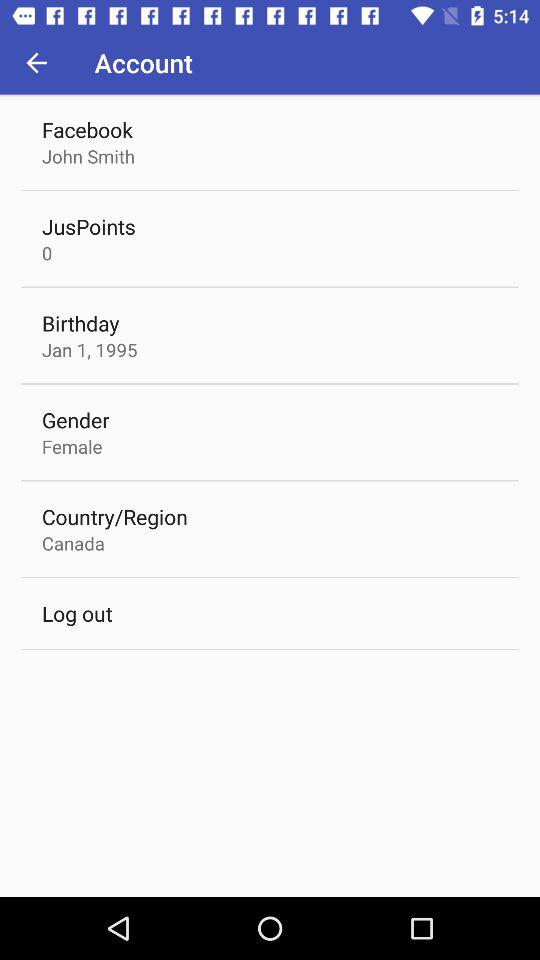What's the name? The given name is John Smith. 